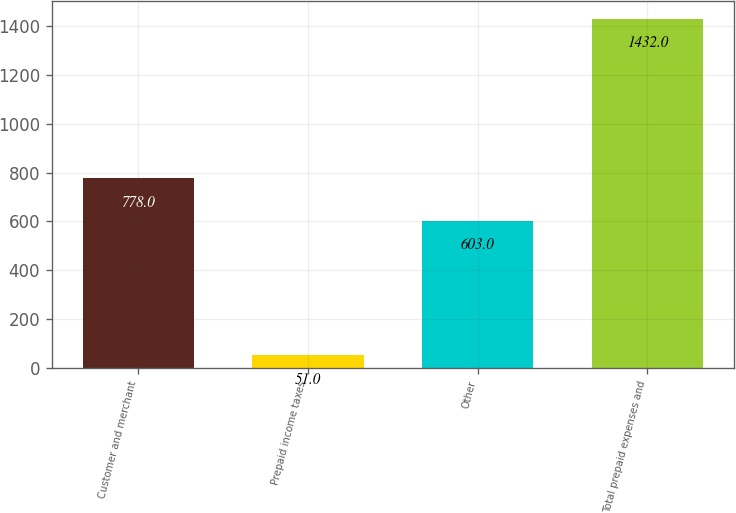Convert chart to OTSL. <chart><loc_0><loc_0><loc_500><loc_500><bar_chart><fcel>Customer and merchant<fcel>Prepaid income taxes<fcel>Other<fcel>Total prepaid expenses and<nl><fcel>778<fcel>51<fcel>603<fcel>1432<nl></chart> 